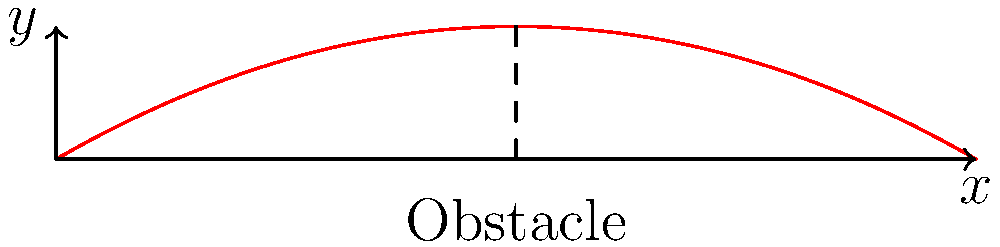A mountain biker jumps over an obstacle with an initial velocity of 10 m/s at a launch angle of 30° from the horizontal. What is the maximum height reached by the biker during the jump? To find the maximum height, we'll follow these steps:

1) The vertical component of velocity is given by:
   $v_y = v_0 \sin(\theta) = 10 \sin(30°) = 5$ m/s

2) The time to reach maximum height is when the vertical velocity becomes zero:
   $t = \frac{v_y}{g} = \frac{5}{9.8} \approx 0.51$ seconds

3) The maximum height can be calculated using the equation:
   $y_{max} = v_y t - \frac{1}{2}gt^2$

4) Substituting the values:
   $y_{max} = 5 \cdot 0.51 - \frac{1}{2} \cdot 9.8 \cdot 0.51^2$

5) Calculating:
   $y_{max} = 2.55 - 1.27 = 1.28$ m

Therefore, the maximum height reached by the biker is approximately 1.28 meters.
Answer: 1.28 m 